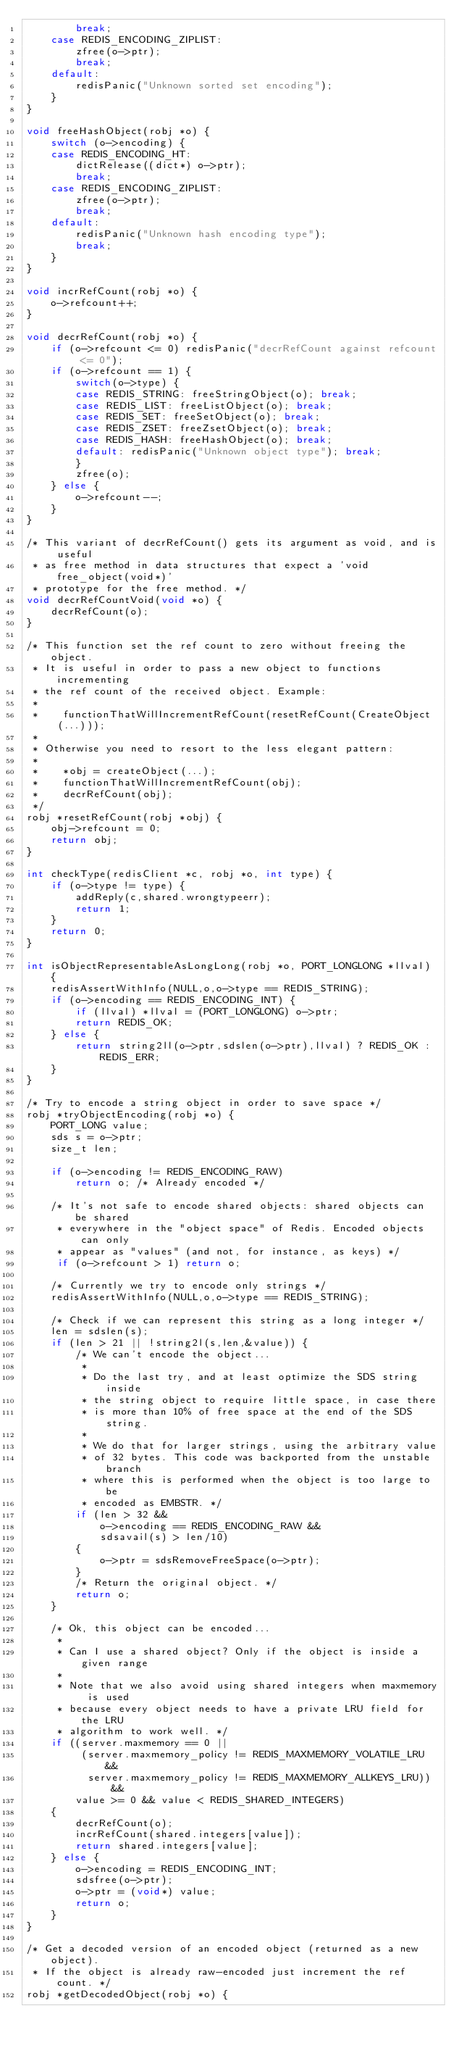<code> <loc_0><loc_0><loc_500><loc_500><_C_>        break;
    case REDIS_ENCODING_ZIPLIST:
        zfree(o->ptr);
        break;
    default:
        redisPanic("Unknown sorted set encoding");
    }
}

void freeHashObject(robj *o) {
    switch (o->encoding) {
    case REDIS_ENCODING_HT:
        dictRelease((dict*) o->ptr);
        break;
    case REDIS_ENCODING_ZIPLIST:
        zfree(o->ptr);
        break;
    default:
        redisPanic("Unknown hash encoding type");
        break;
    }
}

void incrRefCount(robj *o) {
    o->refcount++;
}

void decrRefCount(robj *o) {
    if (o->refcount <= 0) redisPanic("decrRefCount against refcount <= 0");
    if (o->refcount == 1) {
        switch(o->type) {
        case REDIS_STRING: freeStringObject(o); break;
        case REDIS_LIST: freeListObject(o); break;
        case REDIS_SET: freeSetObject(o); break;
        case REDIS_ZSET: freeZsetObject(o); break;
        case REDIS_HASH: freeHashObject(o); break;
        default: redisPanic("Unknown object type"); break;
        }
        zfree(o);
    } else {
        o->refcount--;
    }
}

/* This variant of decrRefCount() gets its argument as void, and is useful
 * as free method in data structures that expect a 'void free_object(void*)'
 * prototype for the free method. */
void decrRefCountVoid(void *o) {
    decrRefCount(o);
}

/* This function set the ref count to zero without freeing the object.
 * It is useful in order to pass a new object to functions incrementing
 * the ref count of the received object. Example:
 *
 *    functionThatWillIncrementRefCount(resetRefCount(CreateObject(...)));
 *
 * Otherwise you need to resort to the less elegant pattern:
 *
 *    *obj = createObject(...);
 *    functionThatWillIncrementRefCount(obj);
 *    decrRefCount(obj);
 */
robj *resetRefCount(robj *obj) {
    obj->refcount = 0;
    return obj;
}

int checkType(redisClient *c, robj *o, int type) {
    if (o->type != type) {
        addReply(c,shared.wrongtypeerr);
        return 1;
    }
    return 0;
}

int isObjectRepresentableAsLongLong(robj *o, PORT_LONGLONG *llval) {
    redisAssertWithInfo(NULL,o,o->type == REDIS_STRING);
    if (o->encoding == REDIS_ENCODING_INT) {
        if (llval) *llval = (PORT_LONGLONG) o->ptr;
        return REDIS_OK;
    } else {
        return string2ll(o->ptr,sdslen(o->ptr),llval) ? REDIS_OK : REDIS_ERR;
    }
}

/* Try to encode a string object in order to save space */
robj *tryObjectEncoding(robj *o) {
    PORT_LONG value;
    sds s = o->ptr;
    size_t len;

    if (o->encoding != REDIS_ENCODING_RAW)
        return o; /* Already encoded */

    /* It's not safe to encode shared objects: shared objects can be shared
     * everywhere in the "object space" of Redis. Encoded objects can only
     * appear as "values" (and not, for instance, as keys) */
     if (o->refcount > 1) return o;

    /* Currently we try to encode only strings */
    redisAssertWithInfo(NULL,o,o->type == REDIS_STRING);

    /* Check if we can represent this string as a long integer */
    len = sdslen(s);
    if (len > 21 || !string2l(s,len,&value)) {
        /* We can't encode the object...
         *
         * Do the last try, and at least optimize the SDS string inside
         * the string object to require little space, in case there
         * is more than 10% of free space at the end of the SDS string.
         *
         * We do that for larger strings, using the arbitrary value
         * of 32 bytes. This code was backported from the unstable branch
         * where this is performed when the object is too large to be
         * encoded as EMBSTR. */
        if (len > 32 &&
            o->encoding == REDIS_ENCODING_RAW &&
            sdsavail(s) > len/10)
        {
            o->ptr = sdsRemoveFreeSpace(o->ptr);
        }
        /* Return the original object. */
        return o;
    }

    /* Ok, this object can be encoded...
     *
     * Can I use a shared object? Only if the object is inside a given range
     *
     * Note that we also avoid using shared integers when maxmemory is used
     * because every object needs to have a private LRU field for the LRU
     * algorithm to work well. */
    if ((server.maxmemory == 0 ||
         (server.maxmemory_policy != REDIS_MAXMEMORY_VOLATILE_LRU &&
          server.maxmemory_policy != REDIS_MAXMEMORY_ALLKEYS_LRU)) &&
        value >= 0 && value < REDIS_SHARED_INTEGERS)
    {
        decrRefCount(o);
        incrRefCount(shared.integers[value]);
        return shared.integers[value];
    } else {
        o->encoding = REDIS_ENCODING_INT;
        sdsfree(o->ptr);
        o->ptr = (void*) value;
        return o;
    }
}

/* Get a decoded version of an encoded object (returned as a new object).
 * If the object is already raw-encoded just increment the ref count. */
robj *getDecodedObject(robj *o) {</code> 